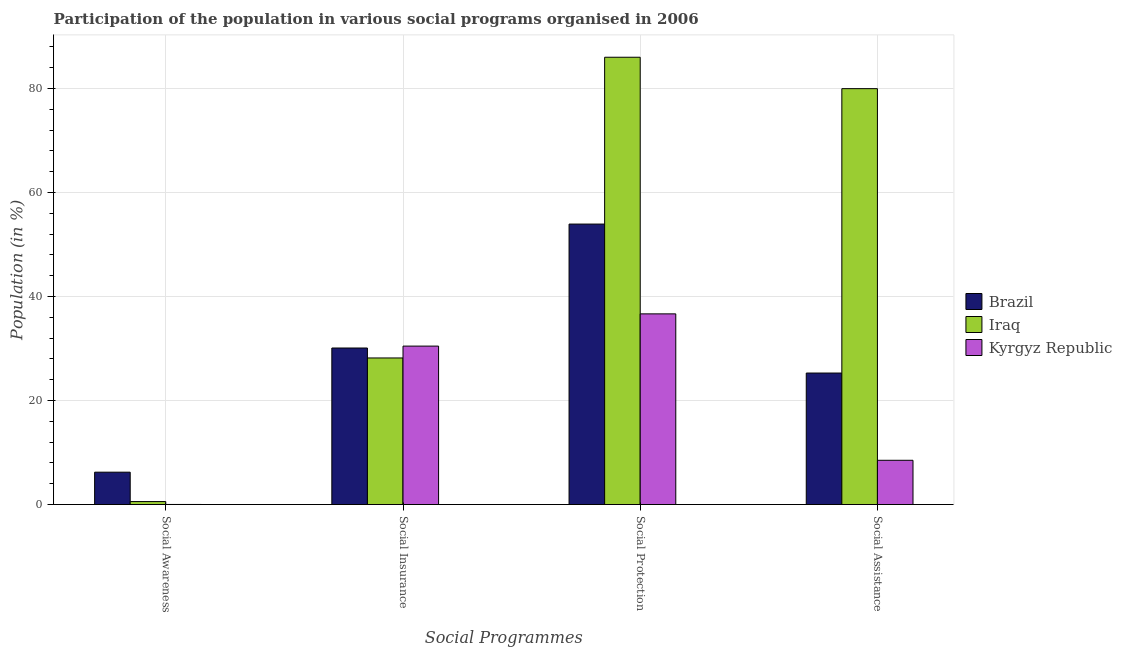How many groups of bars are there?
Your answer should be very brief. 4. Are the number of bars per tick equal to the number of legend labels?
Provide a short and direct response. Yes. Are the number of bars on each tick of the X-axis equal?
Your response must be concise. Yes. How many bars are there on the 1st tick from the left?
Your response must be concise. 3. How many bars are there on the 3rd tick from the right?
Give a very brief answer. 3. What is the label of the 3rd group of bars from the left?
Provide a succinct answer. Social Protection. What is the participation of population in social protection programs in Iraq?
Give a very brief answer. 86.01. Across all countries, what is the maximum participation of population in social insurance programs?
Your answer should be compact. 30.47. Across all countries, what is the minimum participation of population in social awareness programs?
Your answer should be compact. 0.02. In which country was the participation of population in social assistance programs minimum?
Provide a succinct answer. Kyrgyz Republic. What is the total participation of population in social insurance programs in the graph?
Provide a short and direct response. 88.75. What is the difference between the participation of population in social protection programs in Kyrgyz Republic and that in Brazil?
Your answer should be compact. -17.27. What is the difference between the participation of population in social assistance programs in Iraq and the participation of population in social protection programs in Kyrgyz Republic?
Your response must be concise. 43.31. What is the average participation of population in social protection programs per country?
Make the answer very short. 58.87. What is the difference between the participation of population in social assistance programs and participation of population in social insurance programs in Iraq?
Offer a terse response. 51.79. In how many countries, is the participation of population in social protection programs greater than 12 %?
Provide a succinct answer. 3. What is the ratio of the participation of population in social protection programs in Brazil to that in Iraq?
Ensure brevity in your answer.  0.63. Is the difference between the participation of population in social insurance programs in Brazil and Kyrgyz Republic greater than the difference between the participation of population in social protection programs in Brazil and Kyrgyz Republic?
Offer a very short reply. No. What is the difference between the highest and the second highest participation of population in social assistance programs?
Keep it short and to the point. 54.69. What is the difference between the highest and the lowest participation of population in social assistance programs?
Ensure brevity in your answer.  71.46. In how many countries, is the participation of population in social insurance programs greater than the average participation of population in social insurance programs taken over all countries?
Your answer should be very brief. 2. Is the sum of the participation of population in social protection programs in Kyrgyz Republic and Brazil greater than the maximum participation of population in social assistance programs across all countries?
Offer a very short reply. Yes. What does the 1st bar from the left in Social Assistance represents?
Make the answer very short. Brazil. What does the 2nd bar from the right in Social Insurance represents?
Your answer should be very brief. Iraq. Is it the case that in every country, the sum of the participation of population in social awareness programs and participation of population in social insurance programs is greater than the participation of population in social protection programs?
Provide a short and direct response. No. Are all the bars in the graph horizontal?
Ensure brevity in your answer.  No. Are the values on the major ticks of Y-axis written in scientific E-notation?
Ensure brevity in your answer.  No. Does the graph contain grids?
Your answer should be very brief. Yes. Where does the legend appear in the graph?
Your response must be concise. Center right. How many legend labels are there?
Your response must be concise. 3. How are the legend labels stacked?
Offer a terse response. Vertical. What is the title of the graph?
Your answer should be compact. Participation of the population in various social programs organised in 2006. Does "Comoros" appear as one of the legend labels in the graph?
Provide a short and direct response. No. What is the label or title of the X-axis?
Offer a terse response. Social Programmes. What is the label or title of the Y-axis?
Ensure brevity in your answer.  Population (in %). What is the Population (in %) in Brazil in Social Awareness?
Your answer should be very brief. 6.22. What is the Population (in %) in Iraq in Social Awareness?
Your answer should be compact. 0.57. What is the Population (in %) in Kyrgyz Republic in Social Awareness?
Offer a very short reply. 0.02. What is the Population (in %) in Brazil in Social Insurance?
Provide a succinct answer. 30.1. What is the Population (in %) of Iraq in Social Insurance?
Offer a very short reply. 28.19. What is the Population (in %) in Kyrgyz Republic in Social Insurance?
Your answer should be compact. 30.47. What is the Population (in %) of Brazil in Social Protection?
Give a very brief answer. 53.93. What is the Population (in %) of Iraq in Social Protection?
Give a very brief answer. 86.01. What is the Population (in %) of Kyrgyz Republic in Social Protection?
Give a very brief answer. 36.66. What is the Population (in %) in Brazil in Social Assistance?
Provide a short and direct response. 25.29. What is the Population (in %) of Iraq in Social Assistance?
Ensure brevity in your answer.  79.97. What is the Population (in %) in Kyrgyz Republic in Social Assistance?
Provide a succinct answer. 8.51. Across all Social Programmes, what is the maximum Population (in %) in Brazil?
Make the answer very short. 53.93. Across all Social Programmes, what is the maximum Population (in %) in Iraq?
Your response must be concise. 86.01. Across all Social Programmes, what is the maximum Population (in %) in Kyrgyz Republic?
Offer a terse response. 36.66. Across all Social Programmes, what is the minimum Population (in %) of Brazil?
Your response must be concise. 6.22. Across all Social Programmes, what is the minimum Population (in %) in Iraq?
Provide a short and direct response. 0.57. Across all Social Programmes, what is the minimum Population (in %) in Kyrgyz Republic?
Make the answer very short. 0.02. What is the total Population (in %) of Brazil in the graph?
Ensure brevity in your answer.  115.54. What is the total Population (in %) in Iraq in the graph?
Offer a terse response. 194.75. What is the total Population (in %) of Kyrgyz Republic in the graph?
Give a very brief answer. 75.66. What is the difference between the Population (in %) of Brazil in Social Awareness and that in Social Insurance?
Offer a very short reply. -23.88. What is the difference between the Population (in %) of Iraq in Social Awareness and that in Social Insurance?
Your answer should be compact. -27.61. What is the difference between the Population (in %) in Kyrgyz Republic in Social Awareness and that in Social Insurance?
Keep it short and to the point. -30.45. What is the difference between the Population (in %) of Brazil in Social Awareness and that in Social Protection?
Keep it short and to the point. -47.71. What is the difference between the Population (in %) in Iraq in Social Awareness and that in Social Protection?
Give a very brief answer. -85.44. What is the difference between the Population (in %) in Kyrgyz Republic in Social Awareness and that in Social Protection?
Your response must be concise. -36.65. What is the difference between the Population (in %) of Brazil in Social Awareness and that in Social Assistance?
Offer a terse response. -19.07. What is the difference between the Population (in %) in Iraq in Social Awareness and that in Social Assistance?
Give a very brief answer. -79.4. What is the difference between the Population (in %) in Kyrgyz Republic in Social Awareness and that in Social Assistance?
Your answer should be very brief. -8.5. What is the difference between the Population (in %) in Brazil in Social Insurance and that in Social Protection?
Offer a terse response. -23.83. What is the difference between the Population (in %) of Iraq in Social Insurance and that in Social Protection?
Offer a terse response. -57.83. What is the difference between the Population (in %) in Kyrgyz Republic in Social Insurance and that in Social Protection?
Give a very brief answer. -6.2. What is the difference between the Population (in %) in Brazil in Social Insurance and that in Social Assistance?
Your answer should be compact. 4.81. What is the difference between the Population (in %) in Iraq in Social Insurance and that in Social Assistance?
Provide a short and direct response. -51.79. What is the difference between the Population (in %) of Kyrgyz Republic in Social Insurance and that in Social Assistance?
Give a very brief answer. 21.96. What is the difference between the Population (in %) of Brazil in Social Protection and that in Social Assistance?
Your answer should be compact. 28.64. What is the difference between the Population (in %) in Iraq in Social Protection and that in Social Assistance?
Offer a very short reply. 6.04. What is the difference between the Population (in %) of Kyrgyz Republic in Social Protection and that in Social Assistance?
Your answer should be very brief. 28.15. What is the difference between the Population (in %) of Brazil in Social Awareness and the Population (in %) of Iraq in Social Insurance?
Offer a very short reply. -21.96. What is the difference between the Population (in %) in Brazil in Social Awareness and the Population (in %) in Kyrgyz Republic in Social Insurance?
Your answer should be compact. -24.24. What is the difference between the Population (in %) in Iraq in Social Awareness and the Population (in %) in Kyrgyz Republic in Social Insurance?
Keep it short and to the point. -29.89. What is the difference between the Population (in %) of Brazil in Social Awareness and the Population (in %) of Iraq in Social Protection?
Provide a succinct answer. -79.79. What is the difference between the Population (in %) of Brazil in Social Awareness and the Population (in %) of Kyrgyz Republic in Social Protection?
Make the answer very short. -30.44. What is the difference between the Population (in %) of Iraq in Social Awareness and the Population (in %) of Kyrgyz Republic in Social Protection?
Your answer should be very brief. -36.09. What is the difference between the Population (in %) of Brazil in Social Awareness and the Population (in %) of Iraq in Social Assistance?
Your answer should be very brief. -73.75. What is the difference between the Population (in %) of Brazil in Social Awareness and the Population (in %) of Kyrgyz Republic in Social Assistance?
Your response must be concise. -2.29. What is the difference between the Population (in %) of Iraq in Social Awareness and the Population (in %) of Kyrgyz Republic in Social Assistance?
Ensure brevity in your answer.  -7.94. What is the difference between the Population (in %) in Brazil in Social Insurance and the Population (in %) in Iraq in Social Protection?
Provide a succinct answer. -55.91. What is the difference between the Population (in %) in Brazil in Social Insurance and the Population (in %) in Kyrgyz Republic in Social Protection?
Ensure brevity in your answer.  -6.56. What is the difference between the Population (in %) of Iraq in Social Insurance and the Population (in %) of Kyrgyz Republic in Social Protection?
Keep it short and to the point. -8.48. What is the difference between the Population (in %) of Brazil in Social Insurance and the Population (in %) of Iraq in Social Assistance?
Provide a short and direct response. -49.87. What is the difference between the Population (in %) in Brazil in Social Insurance and the Population (in %) in Kyrgyz Republic in Social Assistance?
Your answer should be compact. 21.59. What is the difference between the Population (in %) in Iraq in Social Insurance and the Population (in %) in Kyrgyz Republic in Social Assistance?
Offer a very short reply. 19.68. What is the difference between the Population (in %) of Brazil in Social Protection and the Population (in %) of Iraq in Social Assistance?
Provide a succinct answer. -26.04. What is the difference between the Population (in %) in Brazil in Social Protection and the Population (in %) in Kyrgyz Republic in Social Assistance?
Offer a very short reply. 45.42. What is the difference between the Population (in %) of Iraq in Social Protection and the Population (in %) of Kyrgyz Republic in Social Assistance?
Provide a short and direct response. 77.5. What is the average Population (in %) of Brazil per Social Programmes?
Your answer should be very brief. 28.89. What is the average Population (in %) of Iraq per Social Programmes?
Provide a succinct answer. 48.69. What is the average Population (in %) in Kyrgyz Republic per Social Programmes?
Your response must be concise. 18.91. What is the difference between the Population (in %) in Brazil and Population (in %) in Iraq in Social Awareness?
Provide a succinct answer. 5.65. What is the difference between the Population (in %) of Brazil and Population (in %) of Kyrgyz Republic in Social Awareness?
Make the answer very short. 6.21. What is the difference between the Population (in %) in Iraq and Population (in %) in Kyrgyz Republic in Social Awareness?
Offer a terse response. 0.56. What is the difference between the Population (in %) in Brazil and Population (in %) in Iraq in Social Insurance?
Make the answer very short. 1.92. What is the difference between the Population (in %) of Brazil and Population (in %) of Kyrgyz Republic in Social Insurance?
Ensure brevity in your answer.  -0.37. What is the difference between the Population (in %) of Iraq and Population (in %) of Kyrgyz Republic in Social Insurance?
Your response must be concise. -2.28. What is the difference between the Population (in %) in Brazil and Population (in %) in Iraq in Social Protection?
Offer a very short reply. -32.08. What is the difference between the Population (in %) in Brazil and Population (in %) in Kyrgyz Republic in Social Protection?
Offer a terse response. 17.27. What is the difference between the Population (in %) of Iraq and Population (in %) of Kyrgyz Republic in Social Protection?
Keep it short and to the point. 49.35. What is the difference between the Population (in %) of Brazil and Population (in %) of Iraq in Social Assistance?
Give a very brief answer. -54.69. What is the difference between the Population (in %) of Brazil and Population (in %) of Kyrgyz Republic in Social Assistance?
Offer a very short reply. 16.78. What is the difference between the Population (in %) of Iraq and Population (in %) of Kyrgyz Republic in Social Assistance?
Offer a very short reply. 71.46. What is the ratio of the Population (in %) in Brazil in Social Awareness to that in Social Insurance?
Provide a succinct answer. 0.21. What is the ratio of the Population (in %) in Iraq in Social Awareness to that in Social Insurance?
Your answer should be compact. 0.02. What is the ratio of the Population (in %) of Brazil in Social Awareness to that in Social Protection?
Your answer should be very brief. 0.12. What is the ratio of the Population (in %) of Iraq in Social Awareness to that in Social Protection?
Give a very brief answer. 0.01. What is the ratio of the Population (in %) in Kyrgyz Republic in Social Awareness to that in Social Protection?
Your response must be concise. 0. What is the ratio of the Population (in %) of Brazil in Social Awareness to that in Social Assistance?
Your answer should be compact. 0.25. What is the ratio of the Population (in %) in Iraq in Social Awareness to that in Social Assistance?
Your response must be concise. 0.01. What is the ratio of the Population (in %) of Kyrgyz Republic in Social Awareness to that in Social Assistance?
Make the answer very short. 0. What is the ratio of the Population (in %) in Brazil in Social Insurance to that in Social Protection?
Give a very brief answer. 0.56. What is the ratio of the Population (in %) of Iraq in Social Insurance to that in Social Protection?
Offer a terse response. 0.33. What is the ratio of the Population (in %) of Kyrgyz Republic in Social Insurance to that in Social Protection?
Make the answer very short. 0.83. What is the ratio of the Population (in %) in Brazil in Social Insurance to that in Social Assistance?
Your answer should be compact. 1.19. What is the ratio of the Population (in %) in Iraq in Social Insurance to that in Social Assistance?
Ensure brevity in your answer.  0.35. What is the ratio of the Population (in %) in Kyrgyz Republic in Social Insurance to that in Social Assistance?
Provide a short and direct response. 3.58. What is the ratio of the Population (in %) of Brazil in Social Protection to that in Social Assistance?
Give a very brief answer. 2.13. What is the ratio of the Population (in %) in Iraq in Social Protection to that in Social Assistance?
Provide a short and direct response. 1.08. What is the ratio of the Population (in %) of Kyrgyz Republic in Social Protection to that in Social Assistance?
Your answer should be compact. 4.31. What is the difference between the highest and the second highest Population (in %) in Brazil?
Offer a terse response. 23.83. What is the difference between the highest and the second highest Population (in %) of Iraq?
Offer a very short reply. 6.04. What is the difference between the highest and the second highest Population (in %) in Kyrgyz Republic?
Give a very brief answer. 6.2. What is the difference between the highest and the lowest Population (in %) in Brazil?
Offer a terse response. 47.71. What is the difference between the highest and the lowest Population (in %) of Iraq?
Make the answer very short. 85.44. What is the difference between the highest and the lowest Population (in %) of Kyrgyz Republic?
Make the answer very short. 36.65. 